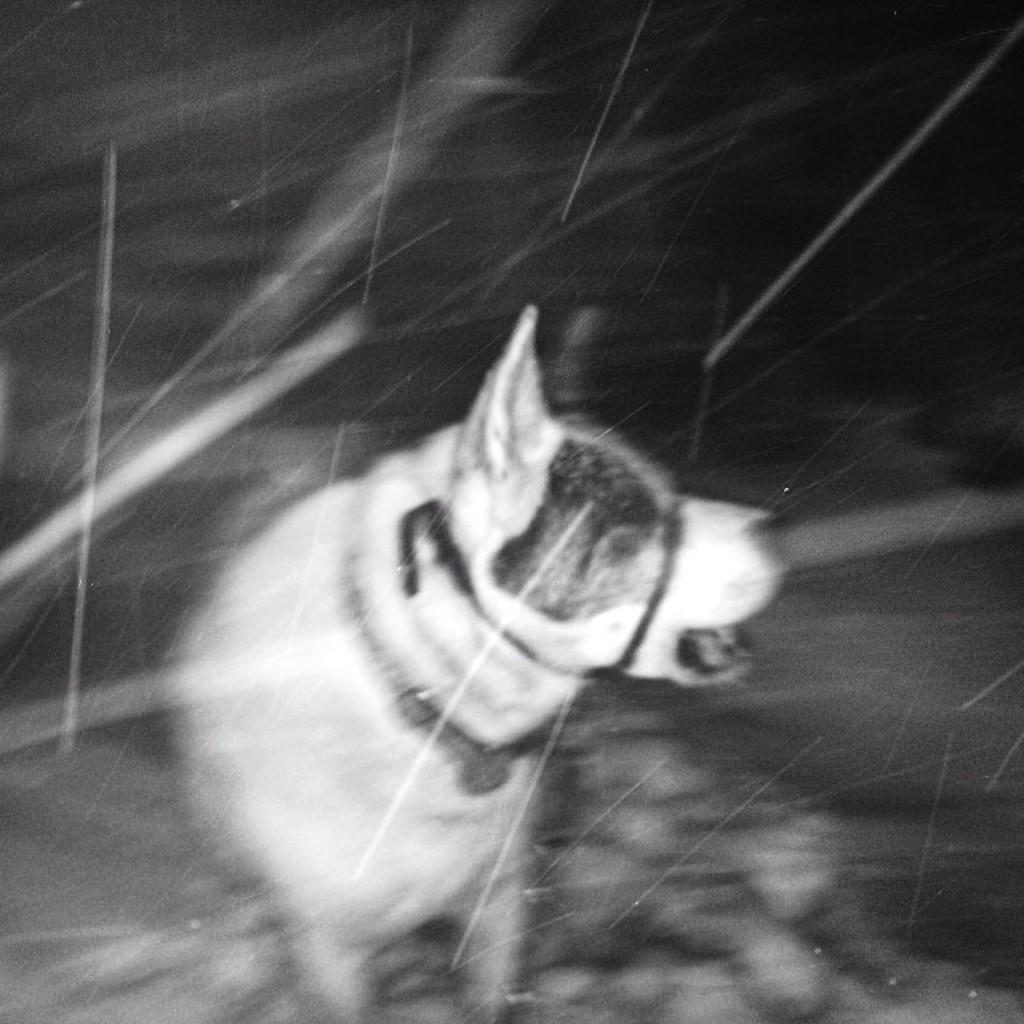What is the color scheme of the image? The image is black and white. What animal can be seen in the image? There is a dog standing in the image. Can you describe the background of the image? The background of the image is blurred. What type of chair is the dog sitting on in the image? There is no chair present in the image; the dog is standing. What memory does the dog have of its past in the image? The image does not provide any information about the dog's memory or past experiences. 